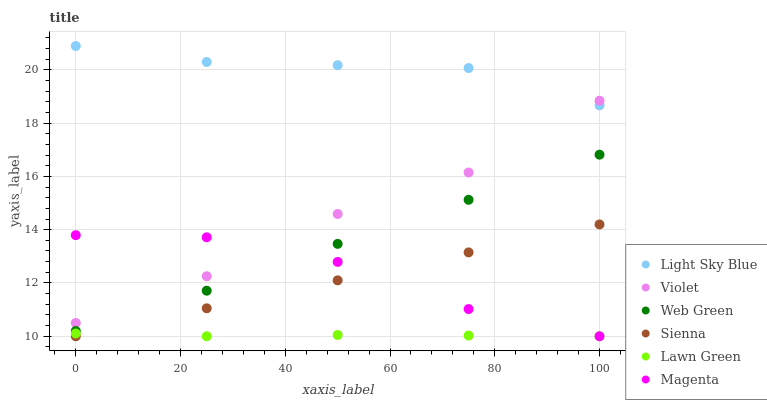Does Lawn Green have the minimum area under the curve?
Answer yes or no. Yes. Does Light Sky Blue have the maximum area under the curve?
Answer yes or no. Yes. Does Web Green have the minimum area under the curve?
Answer yes or no. No. Does Web Green have the maximum area under the curve?
Answer yes or no. No. Is Sienna the smoothest?
Answer yes or no. Yes. Is Violet the roughest?
Answer yes or no. Yes. Is Web Green the smoothest?
Answer yes or no. No. Is Web Green the roughest?
Answer yes or no. No. Does Lawn Green have the lowest value?
Answer yes or no. Yes. Does Web Green have the lowest value?
Answer yes or no. No. Does Light Sky Blue have the highest value?
Answer yes or no. Yes. Does Web Green have the highest value?
Answer yes or no. No. Is Sienna less than Web Green?
Answer yes or no. Yes. Is Web Green greater than Sienna?
Answer yes or no. Yes. Does Violet intersect Magenta?
Answer yes or no. Yes. Is Violet less than Magenta?
Answer yes or no. No. Is Violet greater than Magenta?
Answer yes or no. No. Does Sienna intersect Web Green?
Answer yes or no. No. 